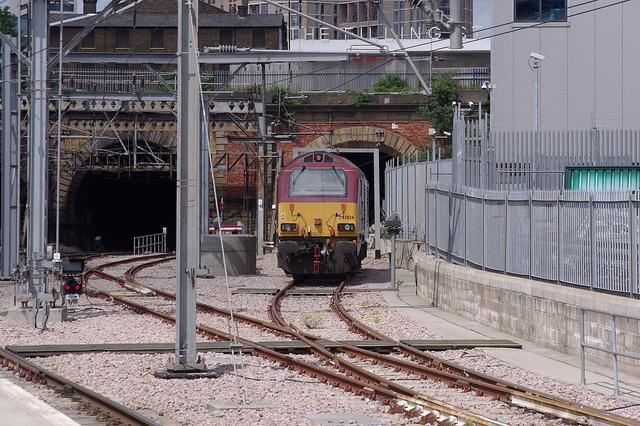How many laptops are visible?
Give a very brief answer. 0. 